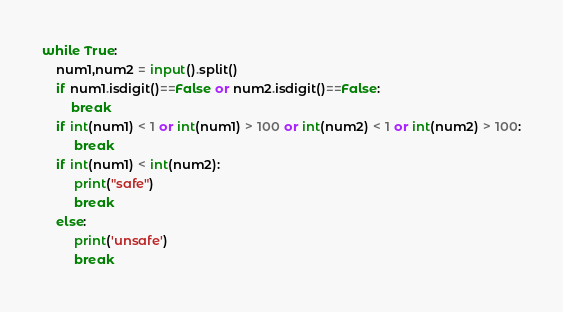Convert code to text. <code><loc_0><loc_0><loc_500><loc_500><_Python_>while True:
    num1,num2 = input().split()
    if num1.isdigit()==False or num2.isdigit()==False:
        break
    if int(num1) < 1 or int(num1) > 100 or int(num2) < 1 or int(num2) > 100:
         break
    if int(num1) < int(num2):
         print("safe")
         break
    else:
         print('unsafe')
         break</code> 